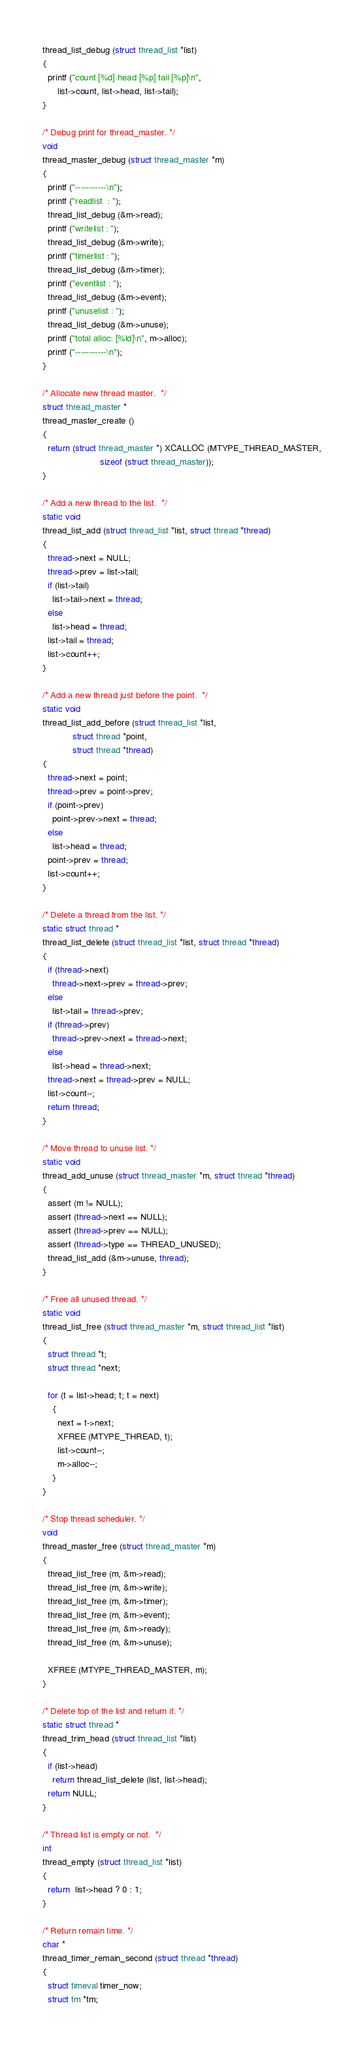<code> <loc_0><loc_0><loc_500><loc_500><_C_>thread_list_debug (struct thread_list *list)
{
  printf ("count [%d] head [%p] tail [%p]\n",
	  list->count, list->head, list->tail);
}

/* Debug print for thread_master. */
void
thread_master_debug (struct thread_master *m)
{
  printf ("-----------\n");
  printf ("readlist  : ");
  thread_list_debug (&m->read);
  printf ("writelist : ");
  thread_list_debug (&m->write);
  printf ("timerlist : ");
  thread_list_debug (&m->timer);
  printf ("eventlist : ");
  thread_list_debug (&m->event);
  printf ("unuselist : ");
  thread_list_debug (&m->unuse);
  printf ("total alloc: [%ld]\n", m->alloc);
  printf ("-----------\n");
}

/* Allocate new thread master.  */
struct thread_master *
thread_master_create ()
{
  return (struct thread_master *) XCALLOC (MTYPE_THREAD_MASTER,
					   sizeof (struct thread_master));
}

/* Add a new thread to the list.  */
static void
thread_list_add (struct thread_list *list, struct thread *thread)
{
  thread->next = NULL;
  thread->prev = list->tail;
  if (list->tail)
    list->tail->next = thread;
  else
    list->head = thread;
  list->tail = thread;
  list->count++;
}

/* Add a new thread just before the point.  */
static void
thread_list_add_before (struct thread_list *list, 
			struct thread *point, 
			struct thread *thread)
{
  thread->next = point;
  thread->prev = point->prev;
  if (point->prev)
    point->prev->next = thread;
  else
    list->head = thread;
  point->prev = thread;
  list->count++;
}

/* Delete a thread from the list. */
static struct thread *
thread_list_delete (struct thread_list *list, struct thread *thread)
{
  if (thread->next)
    thread->next->prev = thread->prev;
  else
    list->tail = thread->prev;
  if (thread->prev)
    thread->prev->next = thread->next;
  else
    list->head = thread->next;
  thread->next = thread->prev = NULL;
  list->count--;
  return thread;
}

/* Move thread to unuse list. */
static void
thread_add_unuse (struct thread_master *m, struct thread *thread)
{
  assert (m != NULL);
  assert (thread->next == NULL);
  assert (thread->prev == NULL);
  assert (thread->type == THREAD_UNUSED);
  thread_list_add (&m->unuse, thread);
}

/* Free all unused thread. */
static void
thread_list_free (struct thread_master *m, struct thread_list *list)
{
  struct thread *t;
  struct thread *next;

  for (t = list->head; t; t = next)
    {
      next = t->next;
      XFREE (MTYPE_THREAD, t);
      list->count--;
      m->alloc--;
    }
}

/* Stop thread scheduler. */
void
thread_master_free (struct thread_master *m)
{
  thread_list_free (m, &m->read);
  thread_list_free (m, &m->write);
  thread_list_free (m, &m->timer);
  thread_list_free (m, &m->event);
  thread_list_free (m, &m->ready);
  thread_list_free (m, &m->unuse);

  XFREE (MTYPE_THREAD_MASTER, m);
}

/* Delete top of the list and return it. */
static struct thread *
thread_trim_head (struct thread_list *list)
{
  if (list->head)
    return thread_list_delete (list, list->head);
  return NULL;
}

/* Thread list is empty or not.  */
int
thread_empty (struct thread_list *list)
{
  return  list->head ? 0 : 1;
}

/* Return remain time. */
char *
thread_timer_remain_second (struct thread *thread)
{
  struct timeval timer_now;
  struct tm *tm;</code> 